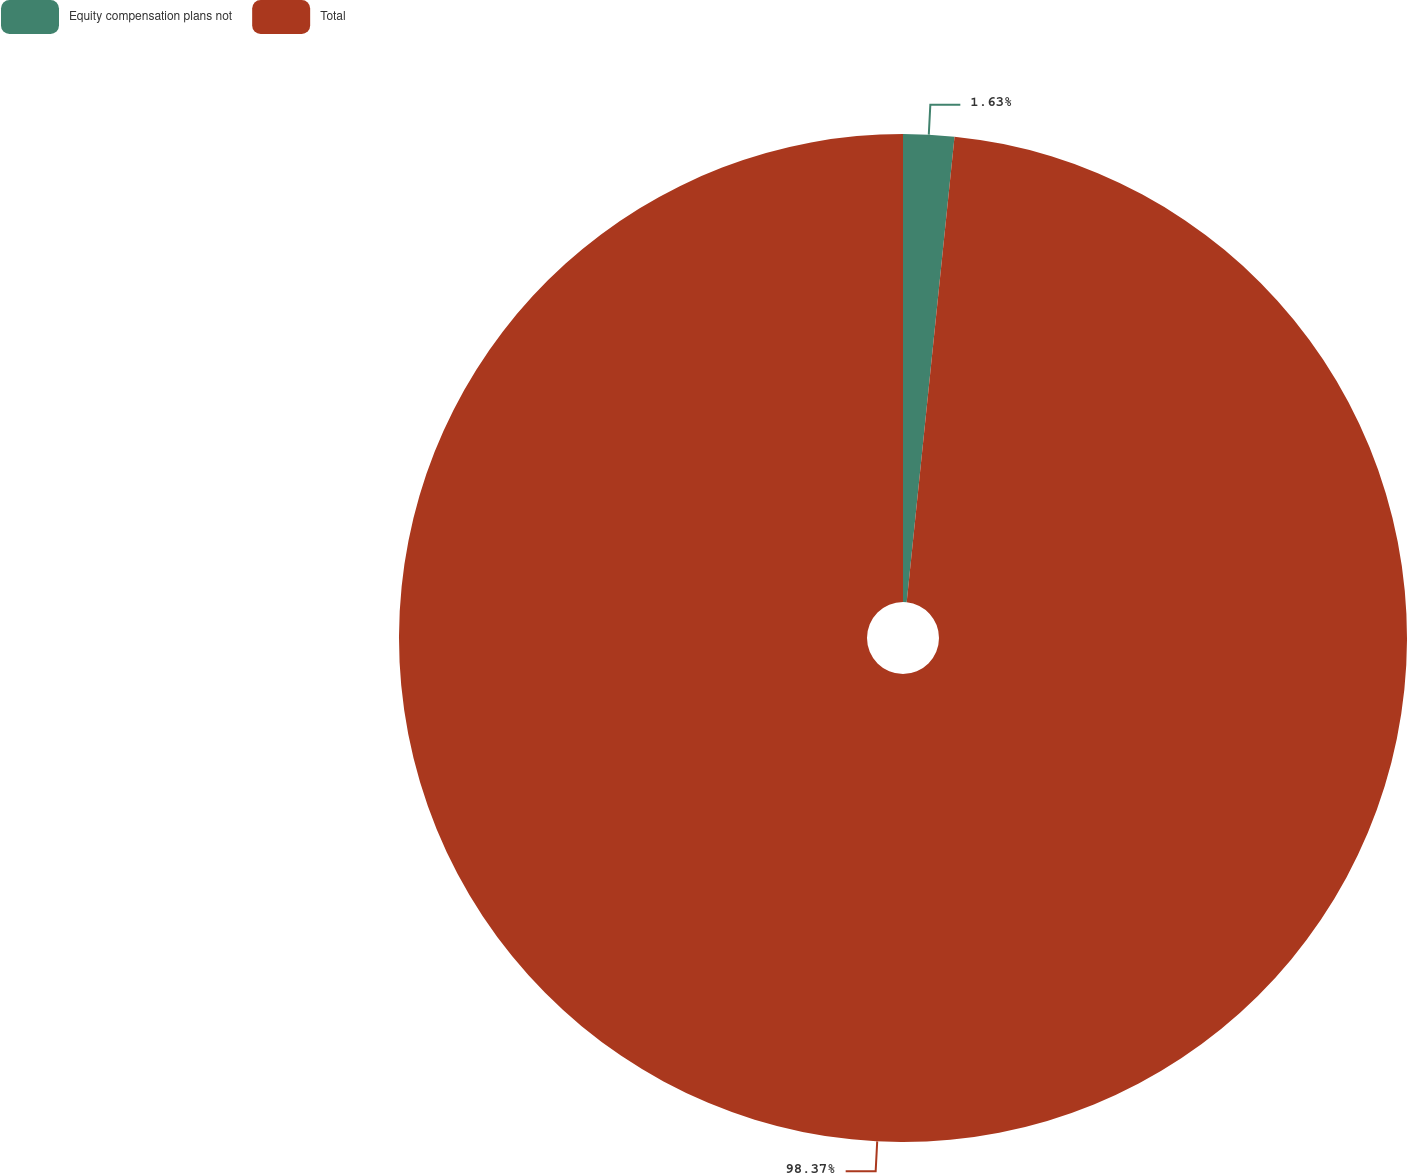Convert chart. <chart><loc_0><loc_0><loc_500><loc_500><pie_chart><fcel>Equity compensation plans not<fcel>Total<nl><fcel>1.63%<fcel>98.37%<nl></chart> 